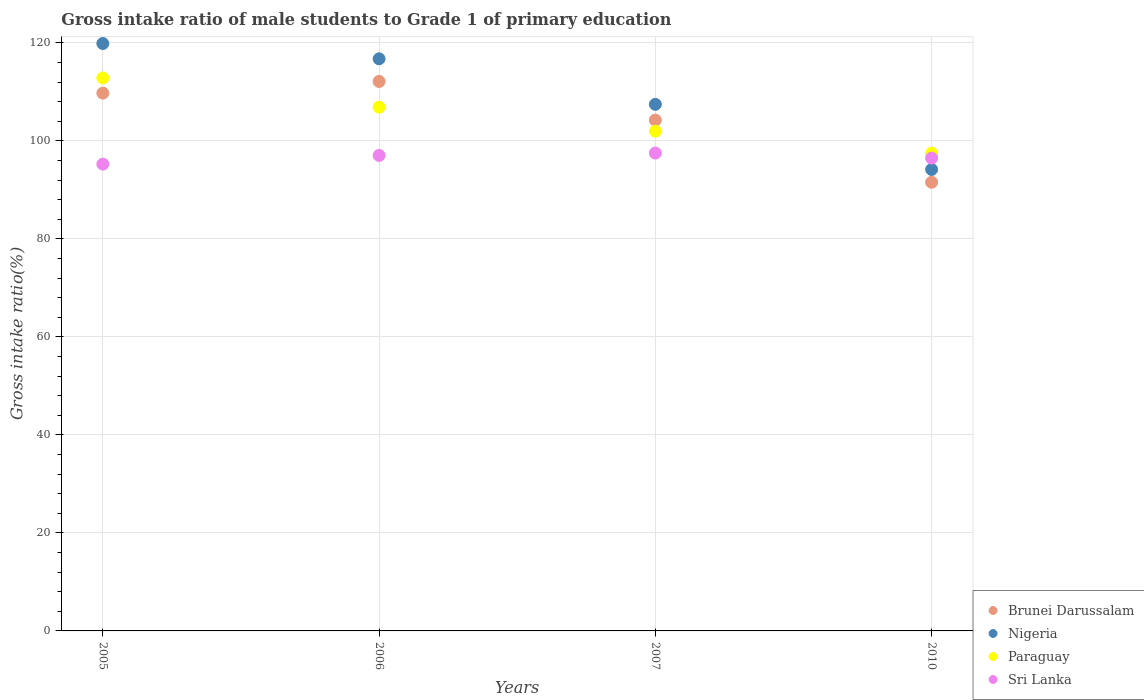What is the gross intake ratio in Brunei Darussalam in 2007?
Give a very brief answer. 104.26. Across all years, what is the maximum gross intake ratio in Paraguay?
Give a very brief answer. 112.85. Across all years, what is the minimum gross intake ratio in Nigeria?
Your answer should be very brief. 94.18. In which year was the gross intake ratio in Sri Lanka minimum?
Your answer should be compact. 2005. What is the total gross intake ratio in Paraguay in the graph?
Provide a succinct answer. 419.24. What is the difference between the gross intake ratio in Brunei Darussalam in 2005 and that in 2007?
Your answer should be very brief. 5.5. What is the difference between the gross intake ratio in Paraguay in 2006 and the gross intake ratio in Brunei Darussalam in 2007?
Ensure brevity in your answer.  2.62. What is the average gross intake ratio in Sri Lanka per year?
Your response must be concise. 96.58. In the year 2005, what is the difference between the gross intake ratio in Paraguay and gross intake ratio in Sri Lanka?
Make the answer very short. 17.58. What is the ratio of the gross intake ratio in Paraguay in 2006 to that in 2007?
Offer a terse response. 1.05. What is the difference between the highest and the second highest gross intake ratio in Sri Lanka?
Offer a very short reply. 0.48. What is the difference between the highest and the lowest gross intake ratio in Brunei Darussalam?
Provide a short and direct response. 20.57. In how many years, is the gross intake ratio in Nigeria greater than the average gross intake ratio in Nigeria taken over all years?
Make the answer very short. 2. Is it the case that in every year, the sum of the gross intake ratio in Nigeria and gross intake ratio in Brunei Darussalam  is greater than the sum of gross intake ratio in Paraguay and gross intake ratio in Sri Lanka?
Ensure brevity in your answer.  No. Is it the case that in every year, the sum of the gross intake ratio in Nigeria and gross intake ratio in Paraguay  is greater than the gross intake ratio in Sri Lanka?
Your response must be concise. Yes. Does the gross intake ratio in Brunei Darussalam monotonically increase over the years?
Make the answer very short. No. Is the gross intake ratio in Brunei Darussalam strictly less than the gross intake ratio in Sri Lanka over the years?
Provide a short and direct response. No. Does the graph contain any zero values?
Provide a succinct answer. No. Where does the legend appear in the graph?
Offer a very short reply. Bottom right. How many legend labels are there?
Ensure brevity in your answer.  4. What is the title of the graph?
Your answer should be very brief. Gross intake ratio of male students to Grade 1 of primary education. What is the label or title of the Y-axis?
Provide a short and direct response. Gross intake ratio(%). What is the Gross intake ratio(%) of Brunei Darussalam in 2005?
Your response must be concise. 109.75. What is the Gross intake ratio(%) of Nigeria in 2005?
Offer a terse response. 119.88. What is the Gross intake ratio(%) of Paraguay in 2005?
Make the answer very short. 112.85. What is the Gross intake ratio(%) in Sri Lanka in 2005?
Give a very brief answer. 95.27. What is the Gross intake ratio(%) in Brunei Darussalam in 2006?
Your answer should be very brief. 112.14. What is the Gross intake ratio(%) in Nigeria in 2006?
Offer a very short reply. 116.76. What is the Gross intake ratio(%) in Paraguay in 2006?
Keep it short and to the point. 106.88. What is the Gross intake ratio(%) in Sri Lanka in 2006?
Your answer should be very brief. 97.04. What is the Gross intake ratio(%) of Brunei Darussalam in 2007?
Offer a very short reply. 104.26. What is the Gross intake ratio(%) of Nigeria in 2007?
Ensure brevity in your answer.  107.47. What is the Gross intake ratio(%) of Paraguay in 2007?
Offer a terse response. 102. What is the Gross intake ratio(%) in Sri Lanka in 2007?
Make the answer very short. 97.52. What is the Gross intake ratio(%) of Brunei Darussalam in 2010?
Ensure brevity in your answer.  91.57. What is the Gross intake ratio(%) of Nigeria in 2010?
Your answer should be very brief. 94.18. What is the Gross intake ratio(%) of Paraguay in 2010?
Provide a short and direct response. 97.51. What is the Gross intake ratio(%) of Sri Lanka in 2010?
Give a very brief answer. 96.5. Across all years, what is the maximum Gross intake ratio(%) of Brunei Darussalam?
Provide a short and direct response. 112.14. Across all years, what is the maximum Gross intake ratio(%) of Nigeria?
Keep it short and to the point. 119.88. Across all years, what is the maximum Gross intake ratio(%) of Paraguay?
Make the answer very short. 112.85. Across all years, what is the maximum Gross intake ratio(%) of Sri Lanka?
Offer a very short reply. 97.52. Across all years, what is the minimum Gross intake ratio(%) of Brunei Darussalam?
Provide a short and direct response. 91.57. Across all years, what is the minimum Gross intake ratio(%) of Nigeria?
Provide a short and direct response. 94.18. Across all years, what is the minimum Gross intake ratio(%) of Paraguay?
Provide a short and direct response. 97.51. Across all years, what is the minimum Gross intake ratio(%) in Sri Lanka?
Offer a very short reply. 95.27. What is the total Gross intake ratio(%) of Brunei Darussalam in the graph?
Ensure brevity in your answer.  417.72. What is the total Gross intake ratio(%) of Nigeria in the graph?
Make the answer very short. 438.29. What is the total Gross intake ratio(%) of Paraguay in the graph?
Provide a short and direct response. 419.24. What is the total Gross intake ratio(%) of Sri Lanka in the graph?
Your response must be concise. 386.33. What is the difference between the Gross intake ratio(%) in Brunei Darussalam in 2005 and that in 2006?
Make the answer very short. -2.39. What is the difference between the Gross intake ratio(%) in Nigeria in 2005 and that in 2006?
Your answer should be very brief. 3.12. What is the difference between the Gross intake ratio(%) of Paraguay in 2005 and that in 2006?
Provide a succinct answer. 5.97. What is the difference between the Gross intake ratio(%) of Sri Lanka in 2005 and that in 2006?
Give a very brief answer. -1.78. What is the difference between the Gross intake ratio(%) of Brunei Darussalam in 2005 and that in 2007?
Keep it short and to the point. 5.5. What is the difference between the Gross intake ratio(%) of Nigeria in 2005 and that in 2007?
Provide a succinct answer. 12.42. What is the difference between the Gross intake ratio(%) of Paraguay in 2005 and that in 2007?
Your response must be concise. 10.85. What is the difference between the Gross intake ratio(%) in Sri Lanka in 2005 and that in 2007?
Ensure brevity in your answer.  -2.26. What is the difference between the Gross intake ratio(%) in Brunei Darussalam in 2005 and that in 2010?
Your answer should be compact. 18.19. What is the difference between the Gross intake ratio(%) of Nigeria in 2005 and that in 2010?
Keep it short and to the point. 25.7. What is the difference between the Gross intake ratio(%) in Paraguay in 2005 and that in 2010?
Keep it short and to the point. 15.34. What is the difference between the Gross intake ratio(%) of Sri Lanka in 2005 and that in 2010?
Provide a short and direct response. -1.23. What is the difference between the Gross intake ratio(%) of Brunei Darussalam in 2006 and that in 2007?
Provide a succinct answer. 7.88. What is the difference between the Gross intake ratio(%) in Nigeria in 2006 and that in 2007?
Your answer should be very brief. 9.3. What is the difference between the Gross intake ratio(%) in Paraguay in 2006 and that in 2007?
Make the answer very short. 4.88. What is the difference between the Gross intake ratio(%) of Sri Lanka in 2006 and that in 2007?
Provide a short and direct response. -0.48. What is the difference between the Gross intake ratio(%) of Brunei Darussalam in 2006 and that in 2010?
Ensure brevity in your answer.  20.57. What is the difference between the Gross intake ratio(%) in Nigeria in 2006 and that in 2010?
Provide a succinct answer. 22.58. What is the difference between the Gross intake ratio(%) in Paraguay in 2006 and that in 2010?
Your response must be concise. 9.38. What is the difference between the Gross intake ratio(%) in Sri Lanka in 2006 and that in 2010?
Ensure brevity in your answer.  0.54. What is the difference between the Gross intake ratio(%) of Brunei Darussalam in 2007 and that in 2010?
Make the answer very short. 12.69. What is the difference between the Gross intake ratio(%) of Nigeria in 2007 and that in 2010?
Provide a short and direct response. 13.29. What is the difference between the Gross intake ratio(%) of Paraguay in 2007 and that in 2010?
Offer a very short reply. 4.49. What is the difference between the Gross intake ratio(%) in Sri Lanka in 2007 and that in 2010?
Offer a terse response. 1.03. What is the difference between the Gross intake ratio(%) in Brunei Darussalam in 2005 and the Gross intake ratio(%) in Nigeria in 2006?
Give a very brief answer. -7.01. What is the difference between the Gross intake ratio(%) of Brunei Darussalam in 2005 and the Gross intake ratio(%) of Paraguay in 2006?
Make the answer very short. 2.87. What is the difference between the Gross intake ratio(%) in Brunei Darussalam in 2005 and the Gross intake ratio(%) in Sri Lanka in 2006?
Offer a very short reply. 12.71. What is the difference between the Gross intake ratio(%) in Nigeria in 2005 and the Gross intake ratio(%) in Paraguay in 2006?
Your response must be concise. 13. What is the difference between the Gross intake ratio(%) in Nigeria in 2005 and the Gross intake ratio(%) in Sri Lanka in 2006?
Your response must be concise. 22.84. What is the difference between the Gross intake ratio(%) in Paraguay in 2005 and the Gross intake ratio(%) in Sri Lanka in 2006?
Provide a short and direct response. 15.81. What is the difference between the Gross intake ratio(%) in Brunei Darussalam in 2005 and the Gross intake ratio(%) in Nigeria in 2007?
Your answer should be very brief. 2.29. What is the difference between the Gross intake ratio(%) in Brunei Darussalam in 2005 and the Gross intake ratio(%) in Paraguay in 2007?
Your answer should be compact. 7.75. What is the difference between the Gross intake ratio(%) in Brunei Darussalam in 2005 and the Gross intake ratio(%) in Sri Lanka in 2007?
Your answer should be compact. 12.23. What is the difference between the Gross intake ratio(%) in Nigeria in 2005 and the Gross intake ratio(%) in Paraguay in 2007?
Offer a very short reply. 17.88. What is the difference between the Gross intake ratio(%) of Nigeria in 2005 and the Gross intake ratio(%) of Sri Lanka in 2007?
Give a very brief answer. 22.36. What is the difference between the Gross intake ratio(%) in Paraguay in 2005 and the Gross intake ratio(%) in Sri Lanka in 2007?
Offer a terse response. 15.33. What is the difference between the Gross intake ratio(%) of Brunei Darussalam in 2005 and the Gross intake ratio(%) of Nigeria in 2010?
Keep it short and to the point. 15.57. What is the difference between the Gross intake ratio(%) in Brunei Darussalam in 2005 and the Gross intake ratio(%) in Paraguay in 2010?
Provide a succinct answer. 12.25. What is the difference between the Gross intake ratio(%) in Brunei Darussalam in 2005 and the Gross intake ratio(%) in Sri Lanka in 2010?
Offer a very short reply. 13.25. What is the difference between the Gross intake ratio(%) in Nigeria in 2005 and the Gross intake ratio(%) in Paraguay in 2010?
Make the answer very short. 22.38. What is the difference between the Gross intake ratio(%) in Nigeria in 2005 and the Gross intake ratio(%) in Sri Lanka in 2010?
Offer a very short reply. 23.38. What is the difference between the Gross intake ratio(%) in Paraguay in 2005 and the Gross intake ratio(%) in Sri Lanka in 2010?
Offer a very short reply. 16.35. What is the difference between the Gross intake ratio(%) of Brunei Darussalam in 2006 and the Gross intake ratio(%) of Nigeria in 2007?
Make the answer very short. 4.67. What is the difference between the Gross intake ratio(%) of Brunei Darussalam in 2006 and the Gross intake ratio(%) of Paraguay in 2007?
Give a very brief answer. 10.14. What is the difference between the Gross intake ratio(%) of Brunei Darussalam in 2006 and the Gross intake ratio(%) of Sri Lanka in 2007?
Offer a very short reply. 14.62. What is the difference between the Gross intake ratio(%) in Nigeria in 2006 and the Gross intake ratio(%) in Paraguay in 2007?
Offer a very short reply. 14.76. What is the difference between the Gross intake ratio(%) of Nigeria in 2006 and the Gross intake ratio(%) of Sri Lanka in 2007?
Your answer should be compact. 19.24. What is the difference between the Gross intake ratio(%) of Paraguay in 2006 and the Gross intake ratio(%) of Sri Lanka in 2007?
Provide a succinct answer. 9.36. What is the difference between the Gross intake ratio(%) in Brunei Darussalam in 2006 and the Gross intake ratio(%) in Nigeria in 2010?
Offer a terse response. 17.96. What is the difference between the Gross intake ratio(%) in Brunei Darussalam in 2006 and the Gross intake ratio(%) in Paraguay in 2010?
Give a very brief answer. 14.63. What is the difference between the Gross intake ratio(%) in Brunei Darussalam in 2006 and the Gross intake ratio(%) in Sri Lanka in 2010?
Your answer should be very brief. 15.64. What is the difference between the Gross intake ratio(%) in Nigeria in 2006 and the Gross intake ratio(%) in Paraguay in 2010?
Provide a succinct answer. 19.26. What is the difference between the Gross intake ratio(%) of Nigeria in 2006 and the Gross intake ratio(%) of Sri Lanka in 2010?
Provide a short and direct response. 20.26. What is the difference between the Gross intake ratio(%) of Paraguay in 2006 and the Gross intake ratio(%) of Sri Lanka in 2010?
Your answer should be very brief. 10.38. What is the difference between the Gross intake ratio(%) of Brunei Darussalam in 2007 and the Gross intake ratio(%) of Nigeria in 2010?
Ensure brevity in your answer.  10.08. What is the difference between the Gross intake ratio(%) in Brunei Darussalam in 2007 and the Gross intake ratio(%) in Paraguay in 2010?
Your answer should be compact. 6.75. What is the difference between the Gross intake ratio(%) in Brunei Darussalam in 2007 and the Gross intake ratio(%) in Sri Lanka in 2010?
Provide a succinct answer. 7.76. What is the difference between the Gross intake ratio(%) in Nigeria in 2007 and the Gross intake ratio(%) in Paraguay in 2010?
Keep it short and to the point. 9.96. What is the difference between the Gross intake ratio(%) of Nigeria in 2007 and the Gross intake ratio(%) of Sri Lanka in 2010?
Provide a short and direct response. 10.97. What is the difference between the Gross intake ratio(%) of Paraguay in 2007 and the Gross intake ratio(%) of Sri Lanka in 2010?
Give a very brief answer. 5.5. What is the average Gross intake ratio(%) of Brunei Darussalam per year?
Offer a terse response. 104.43. What is the average Gross intake ratio(%) of Nigeria per year?
Ensure brevity in your answer.  109.57. What is the average Gross intake ratio(%) in Paraguay per year?
Provide a short and direct response. 104.81. What is the average Gross intake ratio(%) of Sri Lanka per year?
Your answer should be very brief. 96.58. In the year 2005, what is the difference between the Gross intake ratio(%) of Brunei Darussalam and Gross intake ratio(%) of Nigeria?
Provide a succinct answer. -10.13. In the year 2005, what is the difference between the Gross intake ratio(%) in Brunei Darussalam and Gross intake ratio(%) in Paraguay?
Keep it short and to the point. -3.1. In the year 2005, what is the difference between the Gross intake ratio(%) of Brunei Darussalam and Gross intake ratio(%) of Sri Lanka?
Your response must be concise. 14.49. In the year 2005, what is the difference between the Gross intake ratio(%) of Nigeria and Gross intake ratio(%) of Paraguay?
Your answer should be compact. 7.03. In the year 2005, what is the difference between the Gross intake ratio(%) of Nigeria and Gross intake ratio(%) of Sri Lanka?
Make the answer very short. 24.62. In the year 2005, what is the difference between the Gross intake ratio(%) in Paraguay and Gross intake ratio(%) in Sri Lanka?
Provide a short and direct response. 17.58. In the year 2006, what is the difference between the Gross intake ratio(%) in Brunei Darussalam and Gross intake ratio(%) in Nigeria?
Ensure brevity in your answer.  -4.62. In the year 2006, what is the difference between the Gross intake ratio(%) of Brunei Darussalam and Gross intake ratio(%) of Paraguay?
Keep it short and to the point. 5.26. In the year 2006, what is the difference between the Gross intake ratio(%) in Brunei Darussalam and Gross intake ratio(%) in Sri Lanka?
Ensure brevity in your answer.  15.1. In the year 2006, what is the difference between the Gross intake ratio(%) of Nigeria and Gross intake ratio(%) of Paraguay?
Keep it short and to the point. 9.88. In the year 2006, what is the difference between the Gross intake ratio(%) of Nigeria and Gross intake ratio(%) of Sri Lanka?
Your answer should be compact. 19.72. In the year 2006, what is the difference between the Gross intake ratio(%) in Paraguay and Gross intake ratio(%) in Sri Lanka?
Your response must be concise. 9.84. In the year 2007, what is the difference between the Gross intake ratio(%) in Brunei Darussalam and Gross intake ratio(%) in Nigeria?
Your response must be concise. -3.21. In the year 2007, what is the difference between the Gross intake ratio(%) of Brunei Darussalam and Gross intake ratio(%) of Paraguay?
Offer a terse response. 2.26. In the year 2007, what is the difference between the Gross intake ratio(%) of Brunei Darussalam and Gross intake ratio(%) of Sri Lanka?
Ensure brevity in your answer.  6.73. In the year 2007, what is the difference between the Gross intake ratio(%) in Nigeria and Gross intake ratio(%) in Paraguay?
Your answer should be compact. 5.47. In the year 2007, what is the difference between the Gross intake ratio(%) of Nigeria and Gross intake ratio(%) of Sri Lanka?
Provide a succinct answer. 9.94. In the year 2007, what is the difference between the Gross intake ratio(%) in Paraguay and Gross intake ratio(%) in Sri Lanka?
Provide a succinct answer. 4.48. In the year 2010, what is the difference between the Gross intake ratio(%) in Brunei Darussalam and Gross intake ratio(%) in Nigeria?
Your answer should be very brief. -2.61. In the year 2010, what is the difference between the Gross intake ratio(%) in Brunei Darussalam and Gross intake ratio(%) in Paraguay?
Make the answer very short. -5.94. In the year 2010, what is the difference between the Gross intake ratio(%) in Brunei Darussalam and Gross intake ratio(%) in Sri Lanka?
Keep it short and to the point. -4.93. In the year 2010, what is the difference between the Gross intake ratio(%) of Nigeria and Gross intake ratio(%) of Paraguay?
Give a very brief answer. -3.33. In the year 2010, what is the difference between the Gross intake ratio(%) of Nigeria and Gross intake ratio(%) of Sri Lanka?
Provide a short and direct response. -2.32. In the year 2010, what is the difference between the Gross intake ratio(%) of Paraguay and Gross intake ratio(%) of Sri Lanka?
Make the answer very short. 1.01. What is the ratio of the Gross intake ratio(%) in Brunei Darussalam in 2005 to that in 2006?
Give a very brief answer. 0.98. What is the ratio of the Gross intake ratio(%) in Nigeria in 2005 to that in 2006?
Your response must be concise. 1.03. What is the ratio of the Gross intake ratio(%) of Paraguay in 2005 to that in 2006?
Offer a very short reply. 1.06. What is the ratio of the Gross intake ratio(%) of Sri Lanka in 2005 to that in 2006?
Make the answer very short. 0.98. What is the ratio of the Gross intake ratio(%) in Brunei Darussalam in 2005 to that in 2007?
Provide a short and direct response. 1.05. What is the ratio of the Gross intake ratio(%) of Nigeria in 2005 to that in 2007?
Offer a very short reply. 1.12. What is the ratio of the Gross intake ratio(%) of Paraguay in 2005 to that in 2007?
Offer a very short reply. 1.11. What is the ratio of the Gross intake ratio(%) in Sri Lanka in 2005 to that in 2007?
Keep it short and to the point. 0.98. What is the ratio of the Gross intake ratio(%) in Brunei Darussalam in 2005 to that in 2010?
Your response must be concise. 1.2. What is the ratio of the Gross intake ratio(%) of Nigeria in 2005 to that in 2010?
Your response must be concise. 1.27. What is the ratio of the Gross intake ratio(%) in Paraguay in 2005 to that in 2010?
Your answer should be very brief. 1.16. What is the ratio of the Gross intake ratio(%) in Sri Lanka in 2005 to that in 2010?
Provide a short and direct response. 0.99. What is the ratio of the Gross intake ratio(%) of Brunei Darussalam in 2006 to that in 2007?
Provide a short and direct response. 1.08. What is the ratio of the Gross intake ratio(%) of Nigeria in 2006 to that in 2007?
Make the answer very short. 1.09. What is the ratio of the Gross intake ratio(%) of Paraguay in 2006 to that in 2007?
Provide a short and direct response. 1.05. What is the ratio of the Gross intake ratio(%) in Brunei Darussalam in 2006 to that in 2010?
Your response must be concise. 1.22. What is the ratio of the Gross intake ratio(%) in Nigeria in 2006 to that in 2010?
Ensure brevity in your answer.  1.24. What is the ratio of the Gross intake ratio(%) in Paraguay in 2006 to that in 2010?
Your response must be concise. 1.1. What is the ratio of the Gross intake ratio(%) in Sri Lanka in 2006 to that in 2010?
Keep it short and to the point. 1.01. What is the ratio of the Gross intake ratio(%) of Brunei Darussalam in 2007 to that in 2010?
Offer a very short reply. 1.14. What is the ratio of the Gross intake ratio(%) of Nigeria in 2007 to that in 2010?
Provide a short and direct response. 1.14. What is the ratio of the Gross intake ratio(%) of Paraguay in 2007 to that in 2010?
Offer a terse response. 1.05. What is the ratio of the Gross intake ratio(%) in Sri Lanka in 2007 to that in 2010?
Offer a very short reply. 1.01. What is the difference between the highest and the second highest Gross intake ratio(%) of Brunei Darussalam?
Your response must be concise. 2.39. What is the difference between the highest and the second highest Gross intake ratio(%) in Nigeria?
Your answer should be compact. 3.12. What is the difference between the highest and the second highest Gross intake ratio(%) in Paraguay?
Provide a succinct answer. 5.97. What is the difference between the highest and the second highest Gross intake ratio(%) in Sri Lanka?
Ensure brevity in your answer.  0.48. What is the difference between the highest and the lowest Gross intake ratio(%) of Brunei Darussalam?
Make the answer very short. 20.57. What is the difference between the highest and the lowest Gross intake ratio(%) of Nigeria?
Provide a succinct answer. 25.7. What is the difference between the highest and the lowest Gross intake ratio(%) of Paraguay?
Give a very brief answer. 15.34. What is the difference between the highest and the lowest Gross intake ratio(%) in Sri Lanka?
Your answer should be compact. 2.26. 